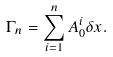<formula> <loc_0><loc_0><loc_500><loc_500>\Gamma _ { n } = \sum _ { i = 1 } ^ { n } A _ { 0 } ^ { i } \delta x .</formula> 